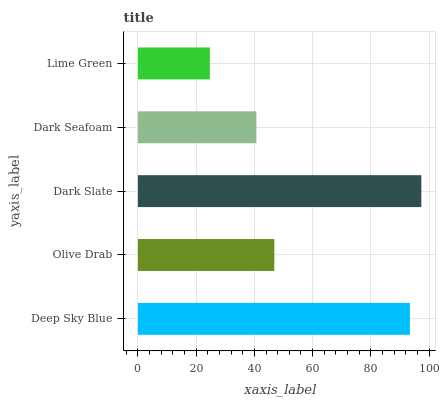Is Lime Green the minimum?
Answer yes or no. Yes. Is Dark Slate the maximum?
Answer yes or no. Yes. Is Olive Drab the minimum?
Answer yes or no. No. Is Olive Drab the maximum?
Answer yes or no. No. Is Deep Sky Blue greater than Olive Drab?
Answer yes or no. Yes. Is Olive Drab less than Deep Sky Blue?
Answer yes or no. Yes. Is Olive Drab greater than Deep Sky Blue?
Answer yes or no. No. Is Deep Sky Blue less than Olive Drab?
Answer yes or no. No. Is Olive Drab the high median?
Answer yes or no. Yes. Is Olive Drab the low median?
Answer yes or no. Yes. Is Deep Sky Blue the high median?
Answer yes or no. No. Is Dark Slate the low median?
Answer yes or no. No. 